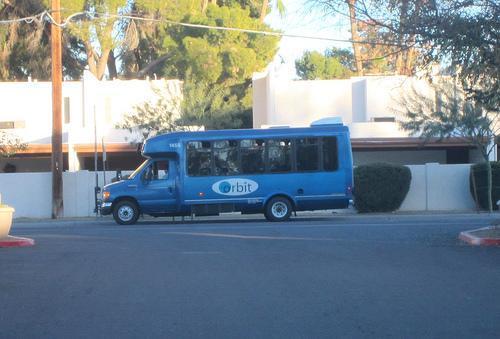How many green buses are there?
Give a very brief answer. 0. 